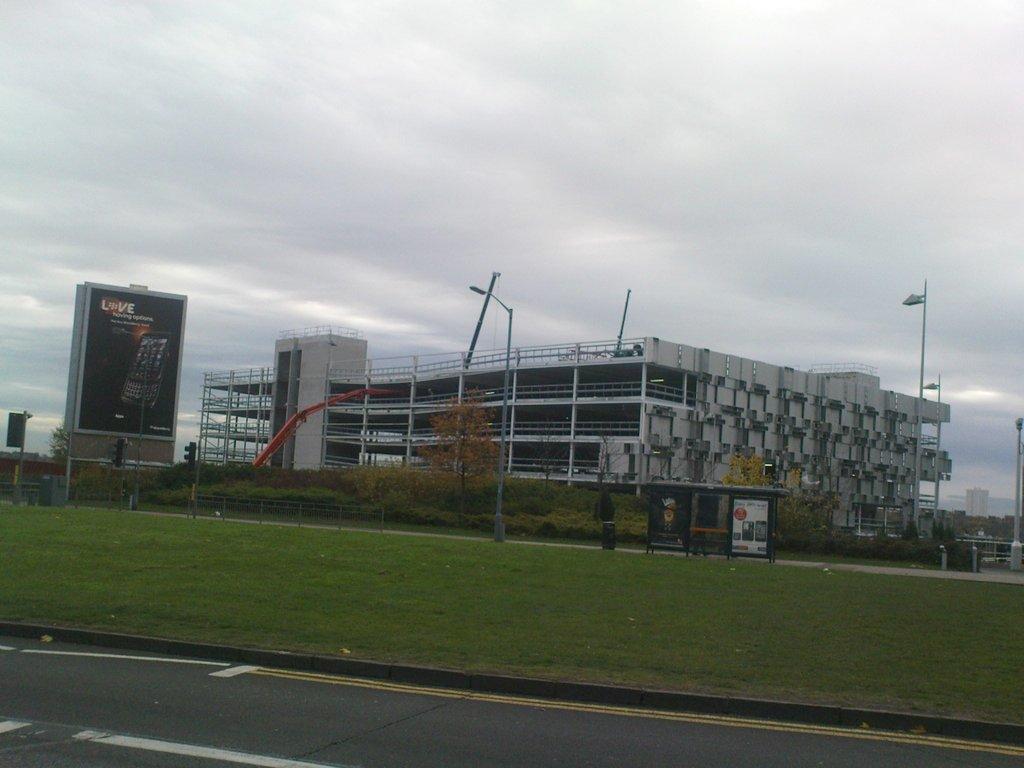Please provide a concise description of this image. In this image at the bottom we can see road and grass on the ground. There are poles, boards, and objects. In the background we can see buildings, crane, poles, plants, objects and clouds in the sky. 